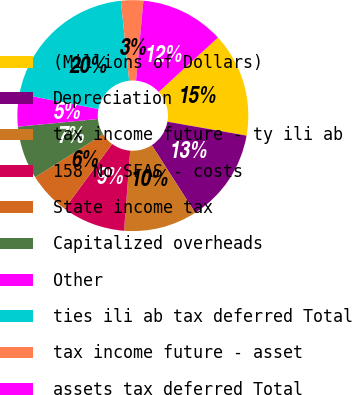<chart> <loc_0><loc_0><loc_500><loc_500><pie_chart><fcel>(Millions of Dollars)<fcel>Depreciation<fcel>tax income future - ty ili ab<fcel>158 No SFAS - costs<fcel>State income tax<fcel>Capitalized overheads<fcel>Other<fcel>ties ili ab tax deferred Total<fcel>tax income future - asset<fcel>assets tax deferred Total<nl><fcel>14.59%<fcel>13.15%<fcel>10.29%<fcel>8.85%<fcel>5.99%<fcel>7.42%<fcel>4.55%<fcel>20.32%<fcel>3.12%<fcel>11.72%<nl></chart> 